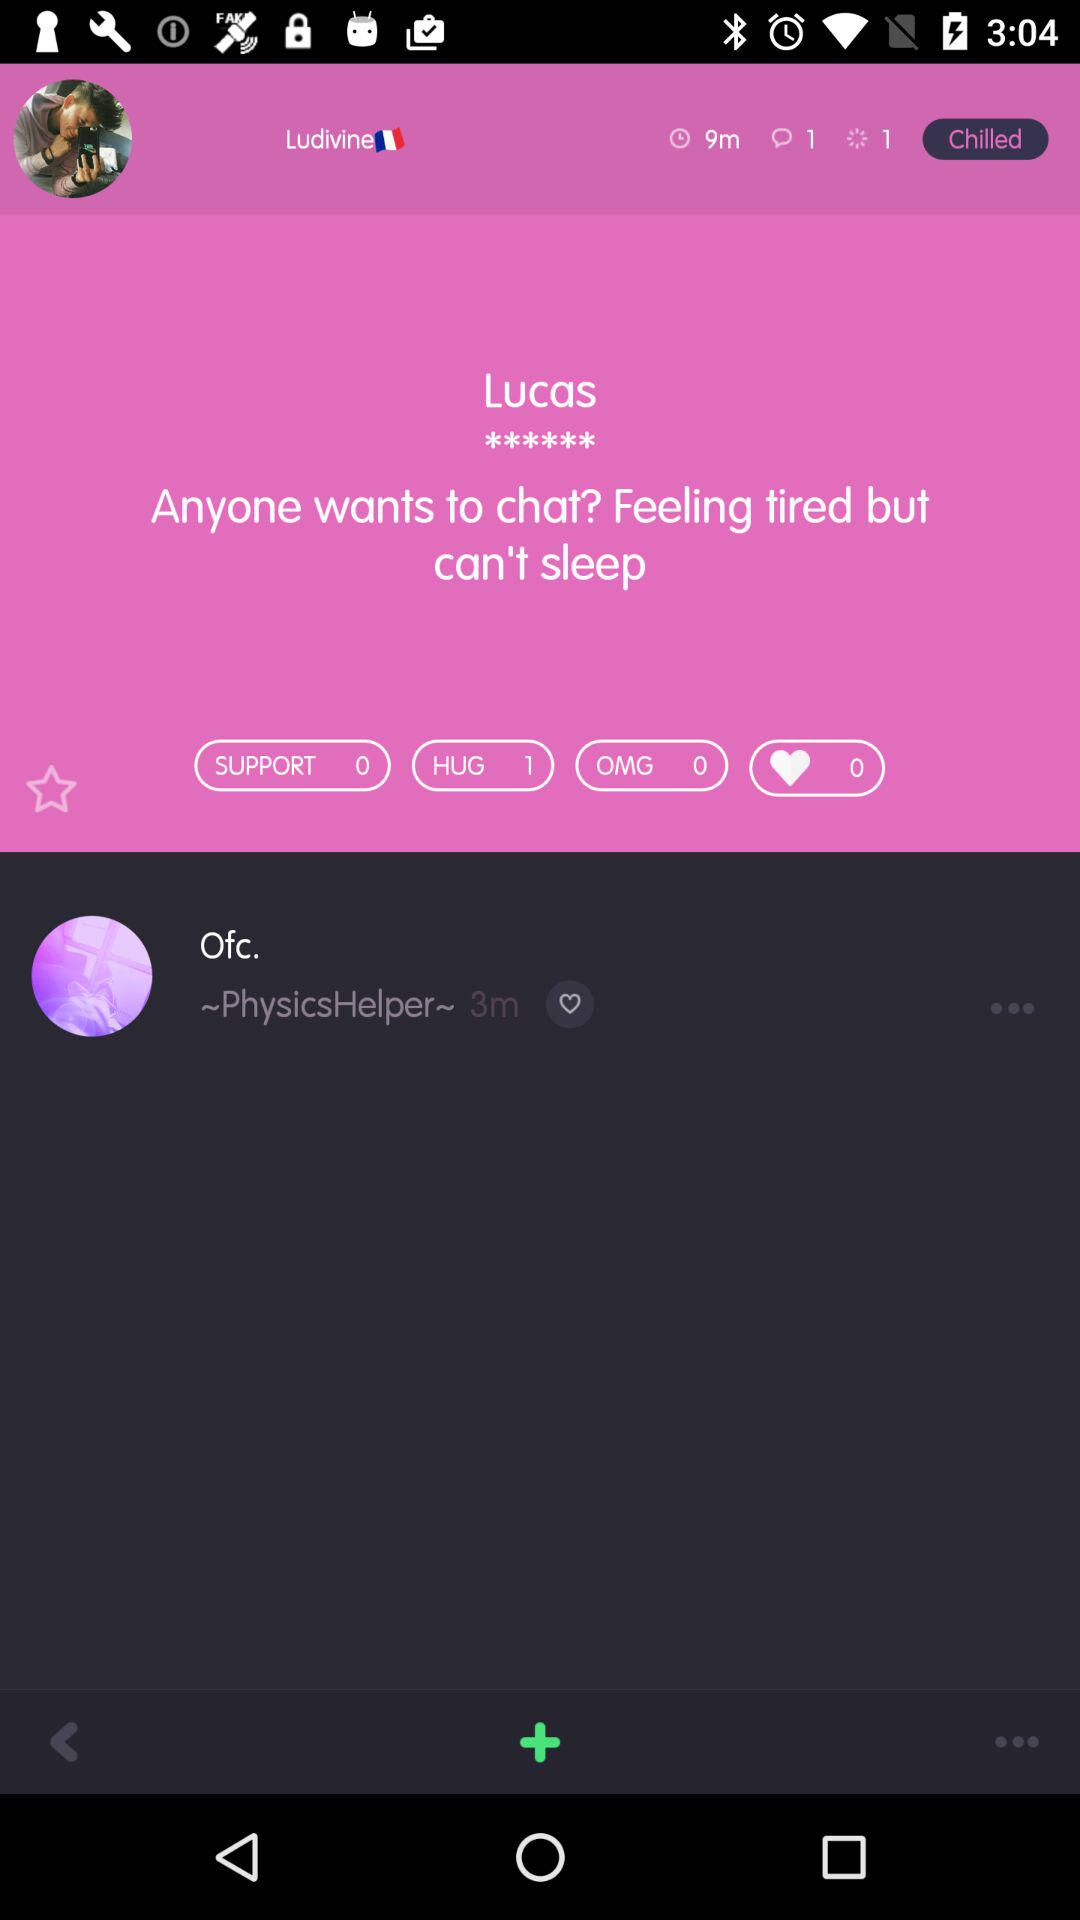How many hugs did Lucas get? Lucas got 1 hug. 